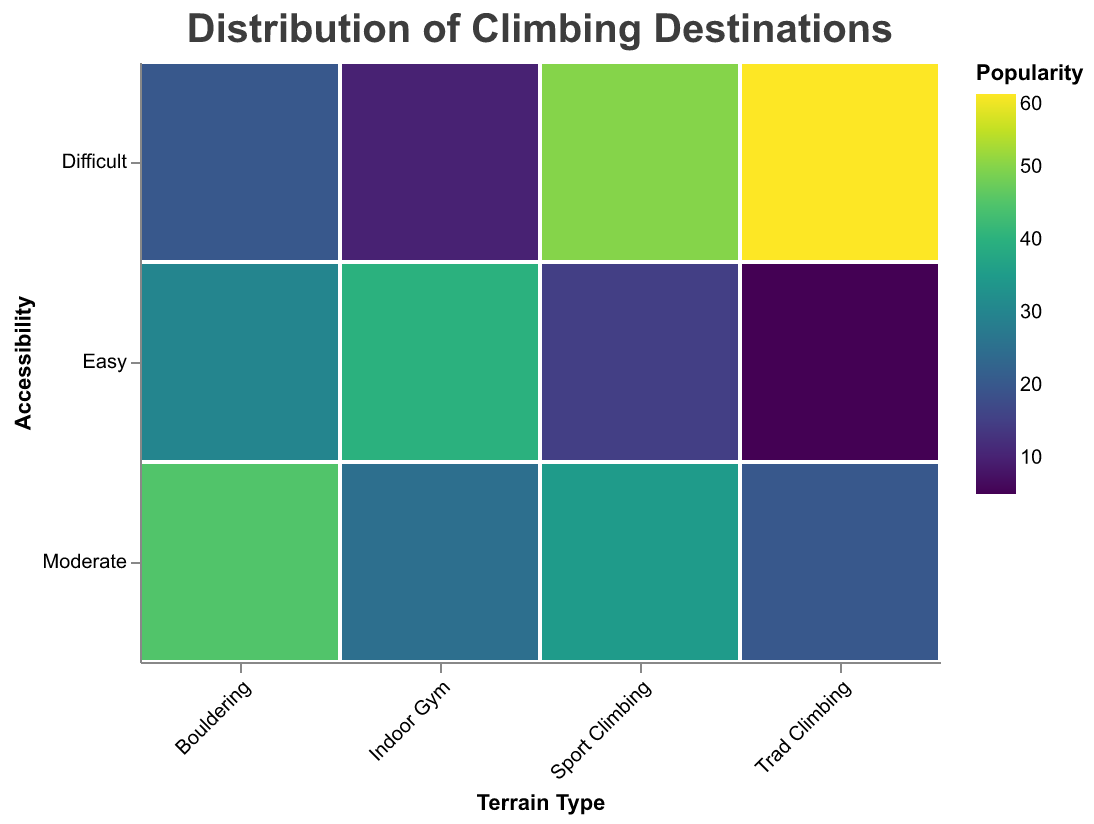What is the title of the plot? The title of the plot is typically located at the top and provides a summary of what the plot represents. In this case, it reads "Distribution of Climbing Destinations."
Answer: Distribution of Climbing Destinations How many terrain types are represented in the plot? The terrain types are shown on the x-axis. By counting the unique categories, we find there are four terrain types: Indoor Gym, Bouldering, Sport Climbing, and Trad Climbing.
Answer: Four Which terrain type has the highest popularity for difficult accessibility? By examining the color shading (with darker indicating higher popularity) for "Difficult" on the y-axis and checking the terrain types, "Trad Climbing" has the darkest shade, indicating the highest popularity.
Answer: Trad Climbing What is the popularity value for easy accessibility in Indoor Gym? Locate "Indoor Gym" on the x-axis and "Easy" on the y-axis. The corresponding value is 40.
Answer: 40 Compare the popularity of Sport Climbing and Bouldering for moderate accessibility. Which one is higher? Find the color shading for "Moderate" on the y-axis for both "Sport Climbing" and "Bouldering." Bouldering shows a darker shade with a value of 45, while Sport Climbing has a value of 35.
Answer: Bouldering What is the sum of popularity values for difficult accessibility across all terrain types? Add the popularity values in the "Difficult" category for all terrain types: 10 (Indoor Gym) + 20 (Bouldering) + 50 (Sport Climbing) + 60 (Trad Climbing) = 140.
Answer: 140 Which terrain type has the lowest popularity for easy accessibility? Examine the values for "Easy" on the y-axis. "Trad Climbing" has the lowest value, which is 5.
Answer: Trad Climbing Is the popularity of Indoor Gym for moderate accessibility higher than that for difficult accessibility? Compare the values for "Moderate" and "Difficult" under Indoor Gym. Moderate has 25, which is higher than Difficult's 10.
Answer: Yes What trend can you infer about the difficulty and popularity for Sport Climbing? Check the popularity values for Sport Climbing along the difficulty spectrum: Easy (15), Moderate (35), and Difficult (50). As the difficulty increases, the popularity also increases.
Answer: Popularity increases with difficulty in Sport Climbing Among the moderate accessibility options, which terrain type appears most popular? Look at the y-axis category "Moderate" and compare the color shading for all terrain types. Bouldering has the darkest shade with a value of 45.
Answer: Bouldering 